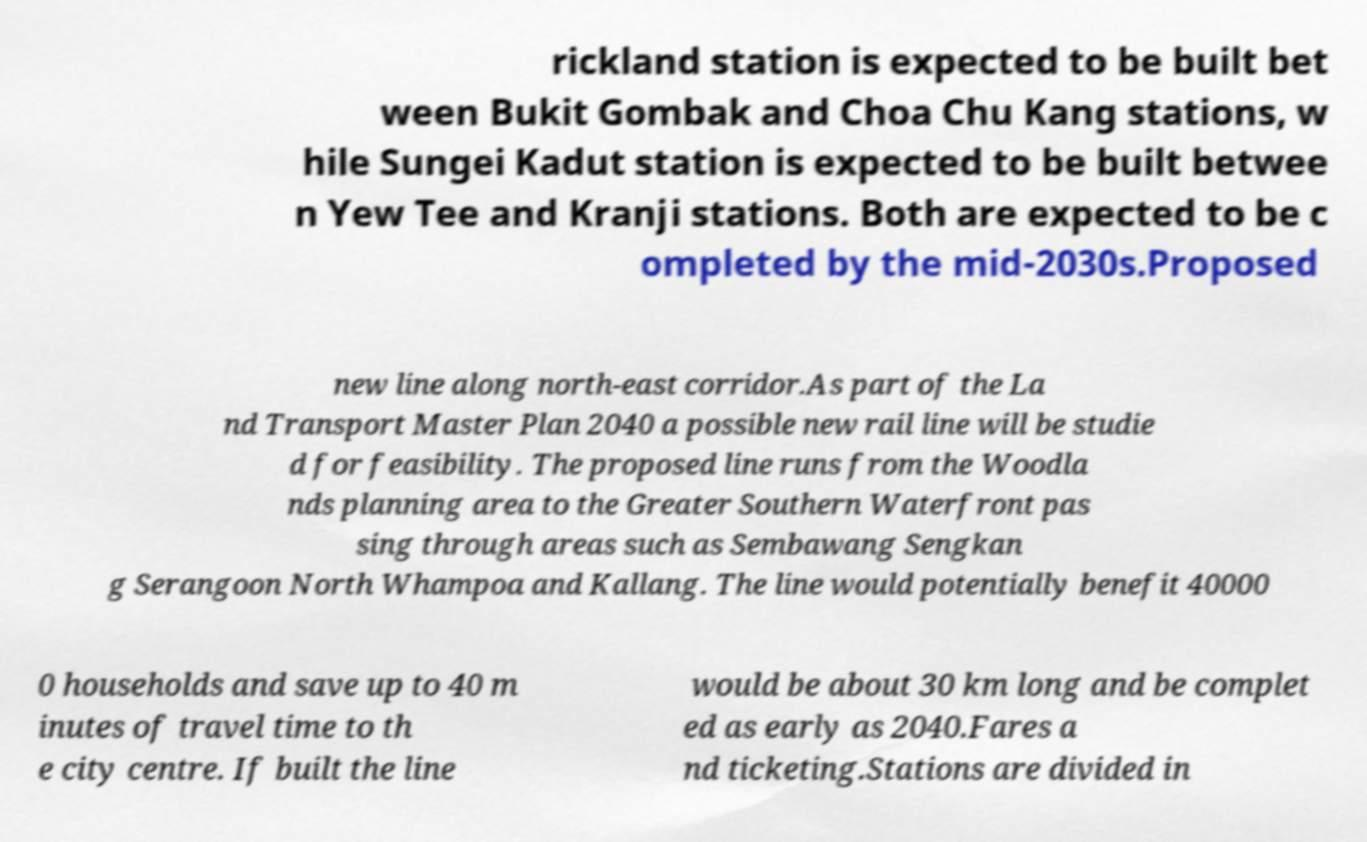Please identify and transcribe the text found in this image. rickland station is expected to be built bet ween Bukit Gombak and Choa Chu Kang stations, w hile Sungei Kadut station is expected to be built betwee n Yew Tee and Kranji stations. Both are expected to be c ompleted by the mid-2030s.Proposed new line along north-east corridor.As part of the La nd Transport Master Plan 2040 a possible new rail line will be studie d for feasibility. The proposed line runs from the Woodla nds planning area to the Greater Southern Waterfront pas sing through areas such as Sembawang Sengkan g Serangoon North Whampoa and Kallang. The line would potentially benefit 40000 0 households and save up to 40 m inutes of travel time to th e city centre. If built the line would be about 30 km long and be complet ed as early as 2040.Fares a nd ticketing.Stations are divided in 